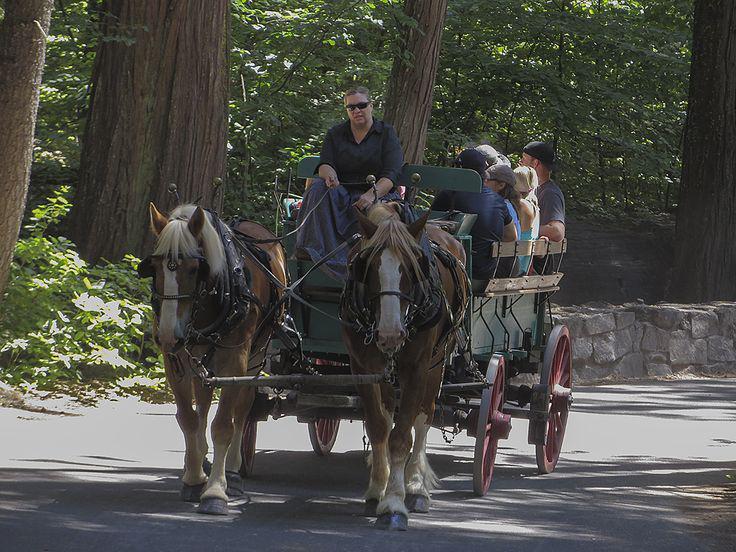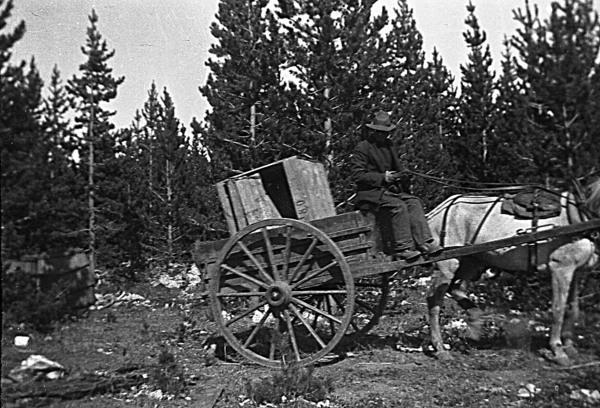The first image is the image on the left, the second image is the image on the right. For the images shown, is this caption "In 1 of the images, 1 carriage has no horse pulling it." true? Answer yes or no. No. The first image is the image on the left, the second image is the image on the right. Considering the images on both sides, is "An image shows a type of cart with no horse attached." valid? Answer yes or no. No. 